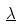Convert formula to latex. <formula><loc_0><loc_0><loc_500><loc_500>\underline { \lambda }</formula> 